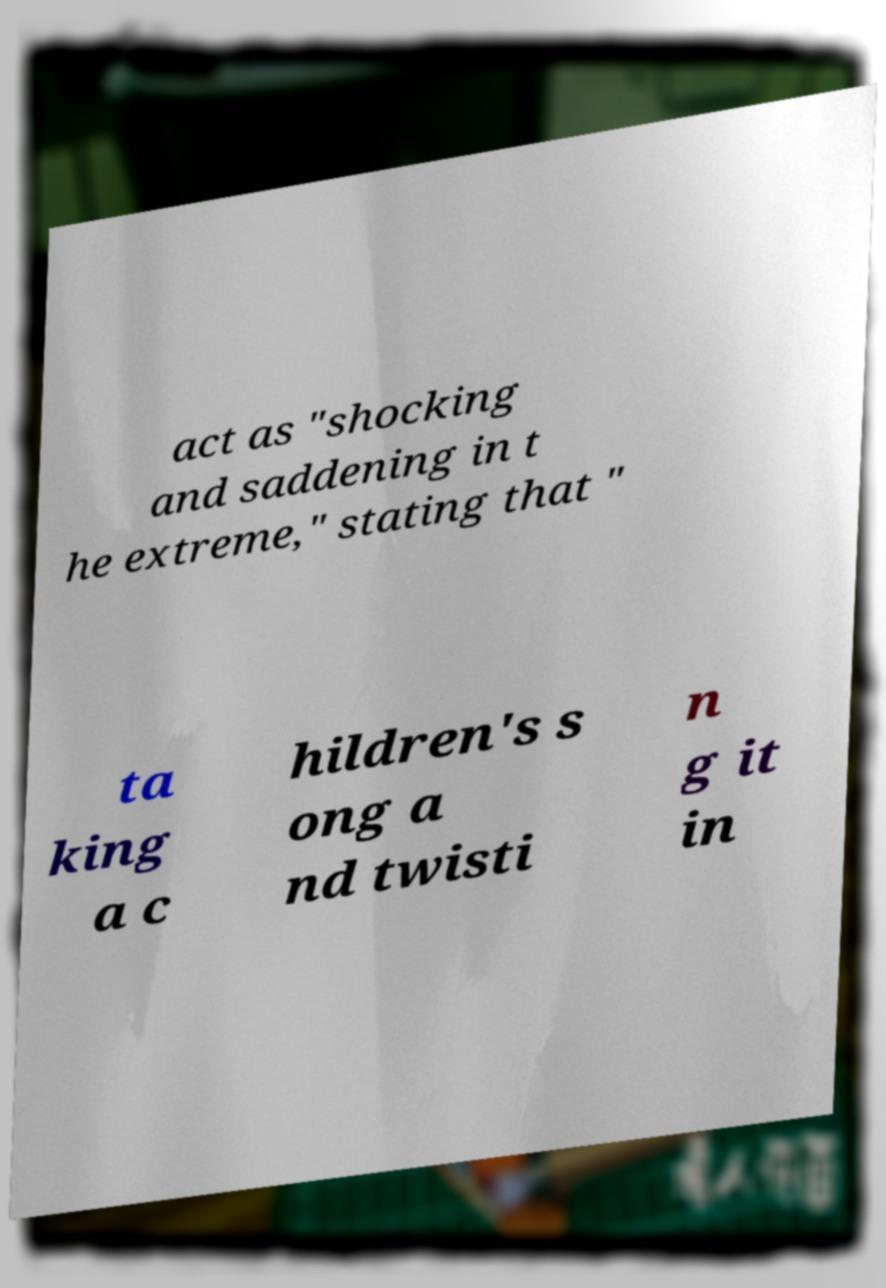Could you extract and type out the text from this image? act as "shocking and saddening in t he extreme," stating that " ta king a c hildren's s ong a nd twisti n g it in 